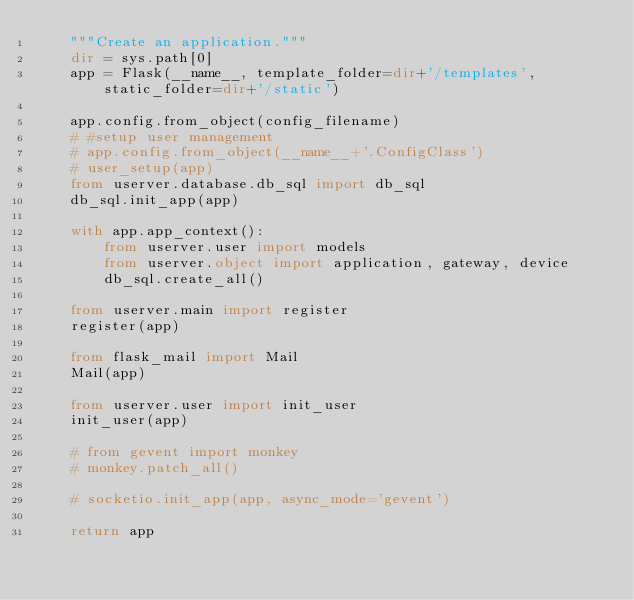<code> <loc_0><loc_0><loc_500><loc_500><_Python_>    """Create an application."""
    dir = sys.path[0]
    app = Flask(__name__, template_folder=dir+'/templates', static_folder=dir+'/static')

    app.config.from_object(config_filename)
    # #setup user management
    # app.config.from_object(__name__+'.ConfigClass')
    # user_setup(app)
    from userver.database.db_sql import db_sql
    db_sql.init_app(app)

    with app.app_context():
        from userver.user import models
        from userver.object import application, gateway, device
        db_sql.create_all()

    from userver.main import register
    register(app)

    from flask_mail import Mail
    Mail(app)

    from userver.user import init_user
    init_user(app)

    # from gevent import monkey
    # monkey.patch_all()

    # socketio.init_app(app, async_mode='gevent')

    return app

</code> 